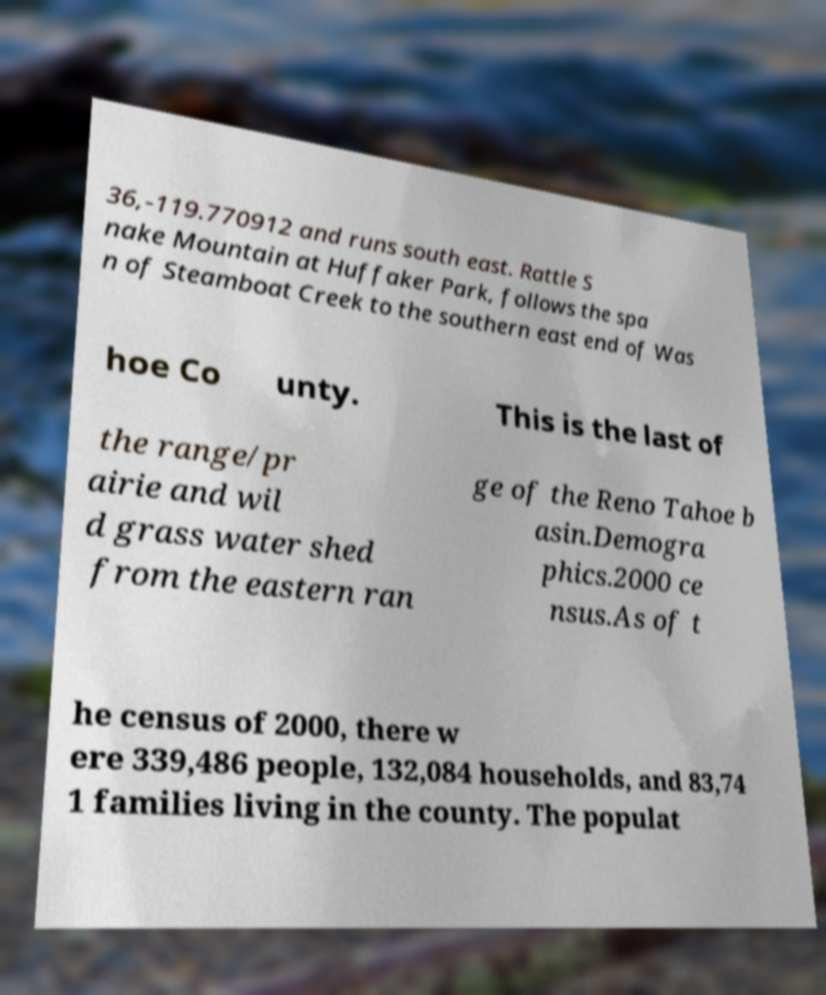For documentation purposes, I need the text within this image transcribed. Could you provide that? 36,-119.770912 and runs south east. Rattle S nake Mountain at Huffaker Park, follows the spa n of Steamboat Creek to the southern east end of Was hoe Co unty. This is the last of the range/pr airie and wil d grass water shed from the eastern ran ge of the Reno Tahoe b asin.Demogra phics.2000 ce nsus.As of t he census of 2000, there w ere 339,486 people, 132,084 households, and 83,74 1 families living in the county. The populat 